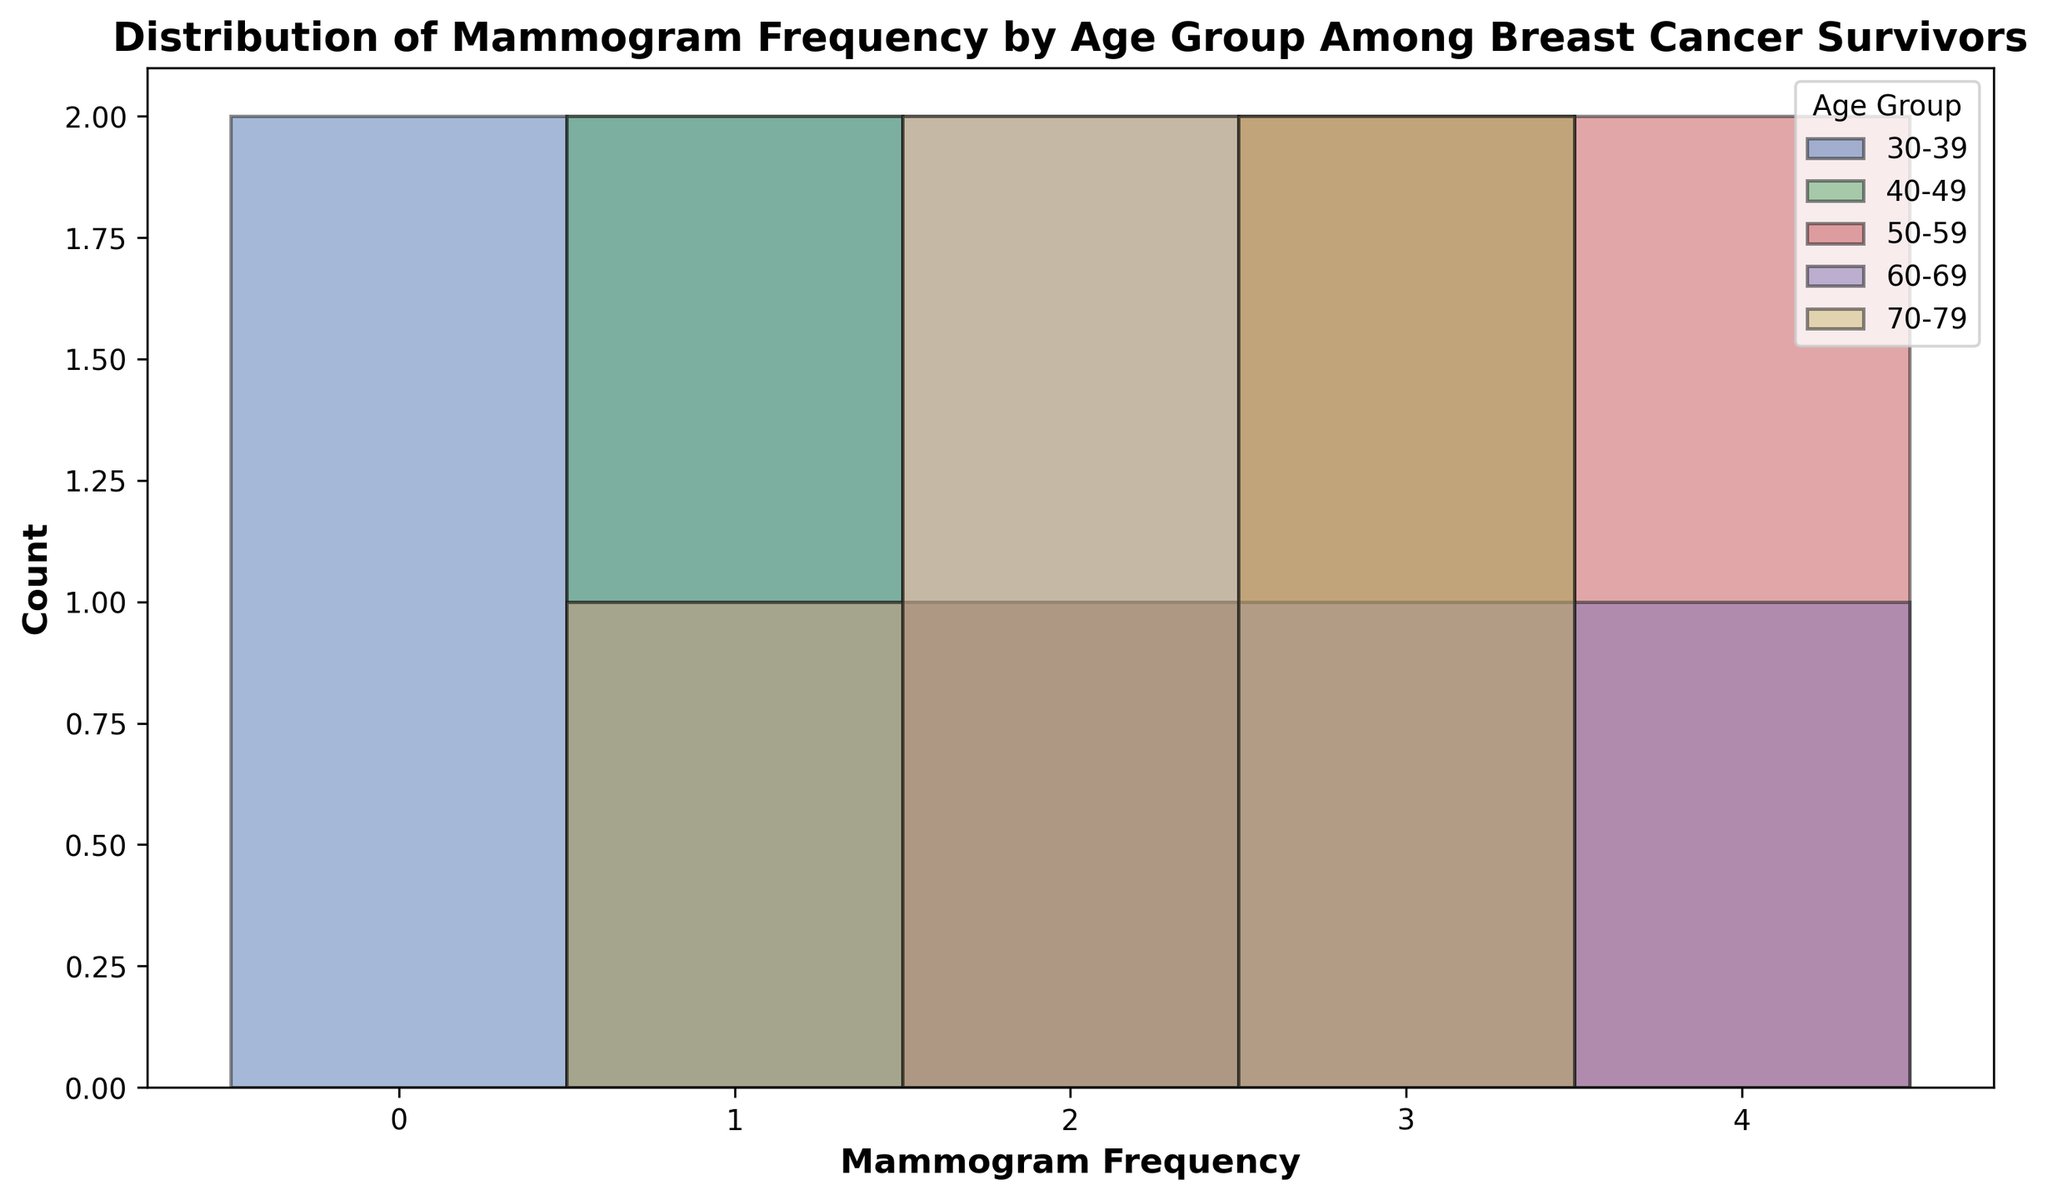How many times is the mammogram frequency of '0' observed in the '30-39' age group? Locate the '30-39' age group in the histogram and count the number of bars corresponding to the mammogram frequency of '0'. Each bar's height represents the count. There are two such bars.
Answer: 2 Which age group has the highest count of mammogram frequency of '3'? Look for the tallest bar among those labeled with mammogram frequency of '3'. The '40-49' age group has the highest bar.
Answer: 40-49 What is the average mammogram frequency for the '70-79' age group? List out all mammogram frequencies for '70-79' (2, 1, 3, 3, 2) and calculate their average. (2+1+3+3+2) / 5 = 2.2
Answer: 2.2 Which age group has the widest range of mammogram frequencies? Identify the frequency range (max - min) for each age group. '50-59' has the widest range, 4-2=2.
Answer: 50-59 Is there an age group where the mammogram frequency of '1' is more common than '2'? Compare the height of the bars for frequencies '1' and '2' within each age group. '40-49' has a higher count for '1' compared to '2'.
Answer: 40-49 What is the total number of recorded mammogram frequencies for the '50-59' age group? Count the number of data points (frequencies) under '50-59'. There are five such points (4, 2, 3, 4, 3).
Answer: 5 Which age group has the least variation in mammogram frequencies? Calculate the difference between the highest and lowest frequencies for each age group. The '30-39' age group has the least variation, ranging from 0 to 2.
Answer: 30-39 How many times is the mammogram frequency of '4' observed in total across all age groups? Sum the counts of bars labeled '4' across all age groups. There are three such bars, two in '50-59' and one in '60-69'.
Answer: 3 